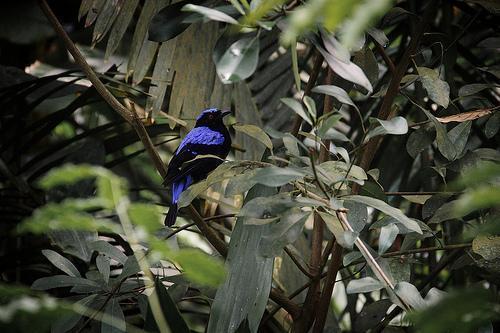How many blue birds are there?
Give a very brief answer. 1. 